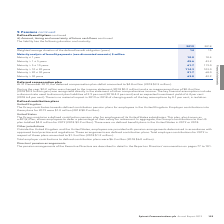According to Spirent Communications Plc's financial document, What information of the liability does the table provide? duration and maturity. The document states: "h flows continued The liability has the following duration and maturity:..." Also, What was the Weighted average duration of the defined benefit obligation (years) in 2019? According to the financial document, 14. The relevant text states: "uration of the defined benefit obligation (years) 14 15..." Also, What are the categories of maturity used in the Maturity analysis of benefit payments (non-discounted amounts)? The document contains multiple relevant values: Maturity ≤ 1 year, Maturity > 1 ≤ 5 years, Maturity > 5 ≤ 10 years, Maturity > 10 ≤ 20 years, Maturity > 20 ≤ 30 years, Maturity > 30 years. From the document: "Maturity > 30 years 63.0 42.9 Maturity ≤ 1 year 10.8 10.4 Maturity > 10 ≤ 20 years 114.3 103.0 Maturity > 5 ≤ 10 years 61.7 119.0 Maturity > 20 ≤ 30 y..." Additionally, In which year was the Weighted average duration of the defined benefit obligation (years) larger? According to the financial document, 2018. The relevant text states: "2019 2018..." Also, can you calculate: What was the change in the benefit payments (non-discounted amounts) for maturity > 30 years? Based on the calculation: 63.0-42.9, the result is 20.1 (in millions). This is based on the information: "Maturity > 30 years 63.0 42.9 Maturity > 30 years 63.0 42.9..." The key data points involved are: 42.9, 63.0. Also, can you calculate: What was the percentage change in the benefit payments (non-discounted amounts) for maturity > 30 years? To answer this question, I need to perform calculations using the financial data. The calculation is: (63.0-42.9)/42.9, which equals 46.85 (percentage). This is based on the information: "Maturity > 30 years 63.0 42.9 Maturity > 30 years 63.0 42.9..." The key data points involved are: 42.9, 63.0. 